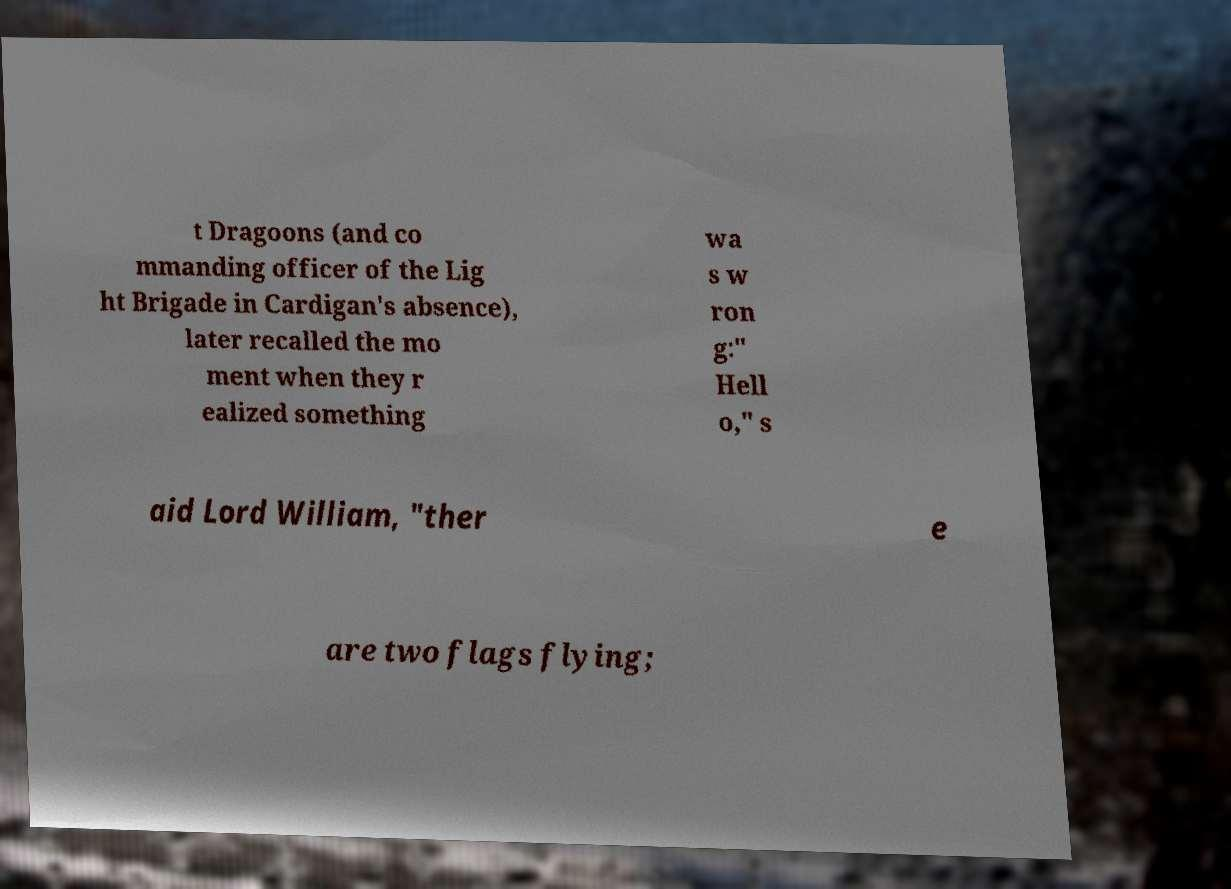Please read and relay the text visible in this image. What does it say? t Dragoons (and co mmanding officer of the Lig ht Brigade in Cardigan's absence), later recalled the mo ment when they r ealized something wa s w ron g:" Hell o," s aid Lord William, "ther e are two flags flying; 